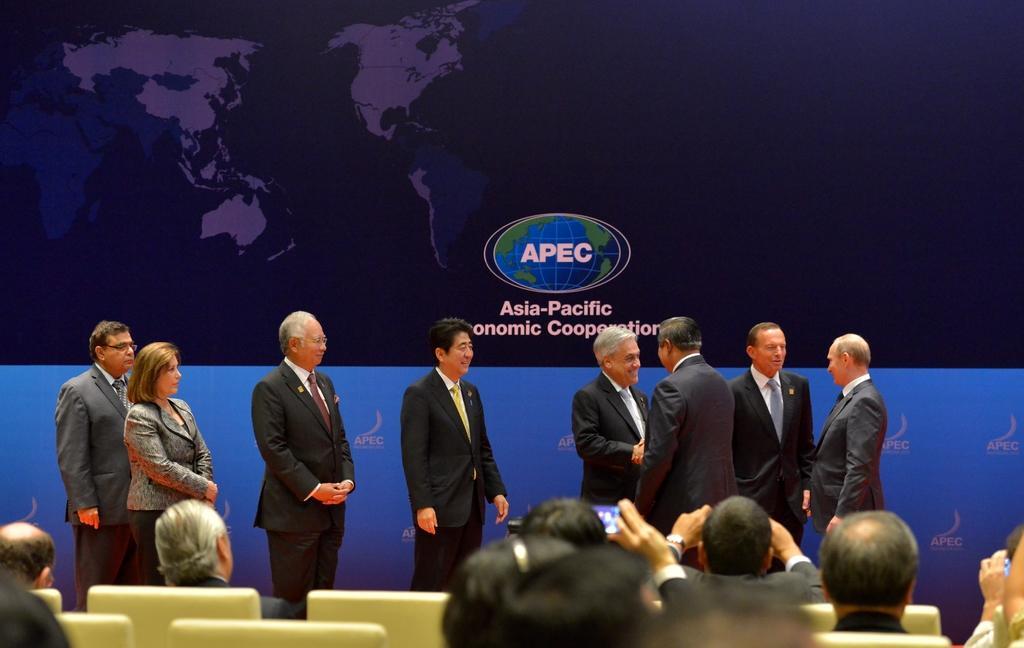Please provide a concise description of this image. In this image I can see few persons are sitting on chairs which are cream in color. I can see number of persons wearing black colored dresses are standing. In the background I can see blue and black colored banner. 